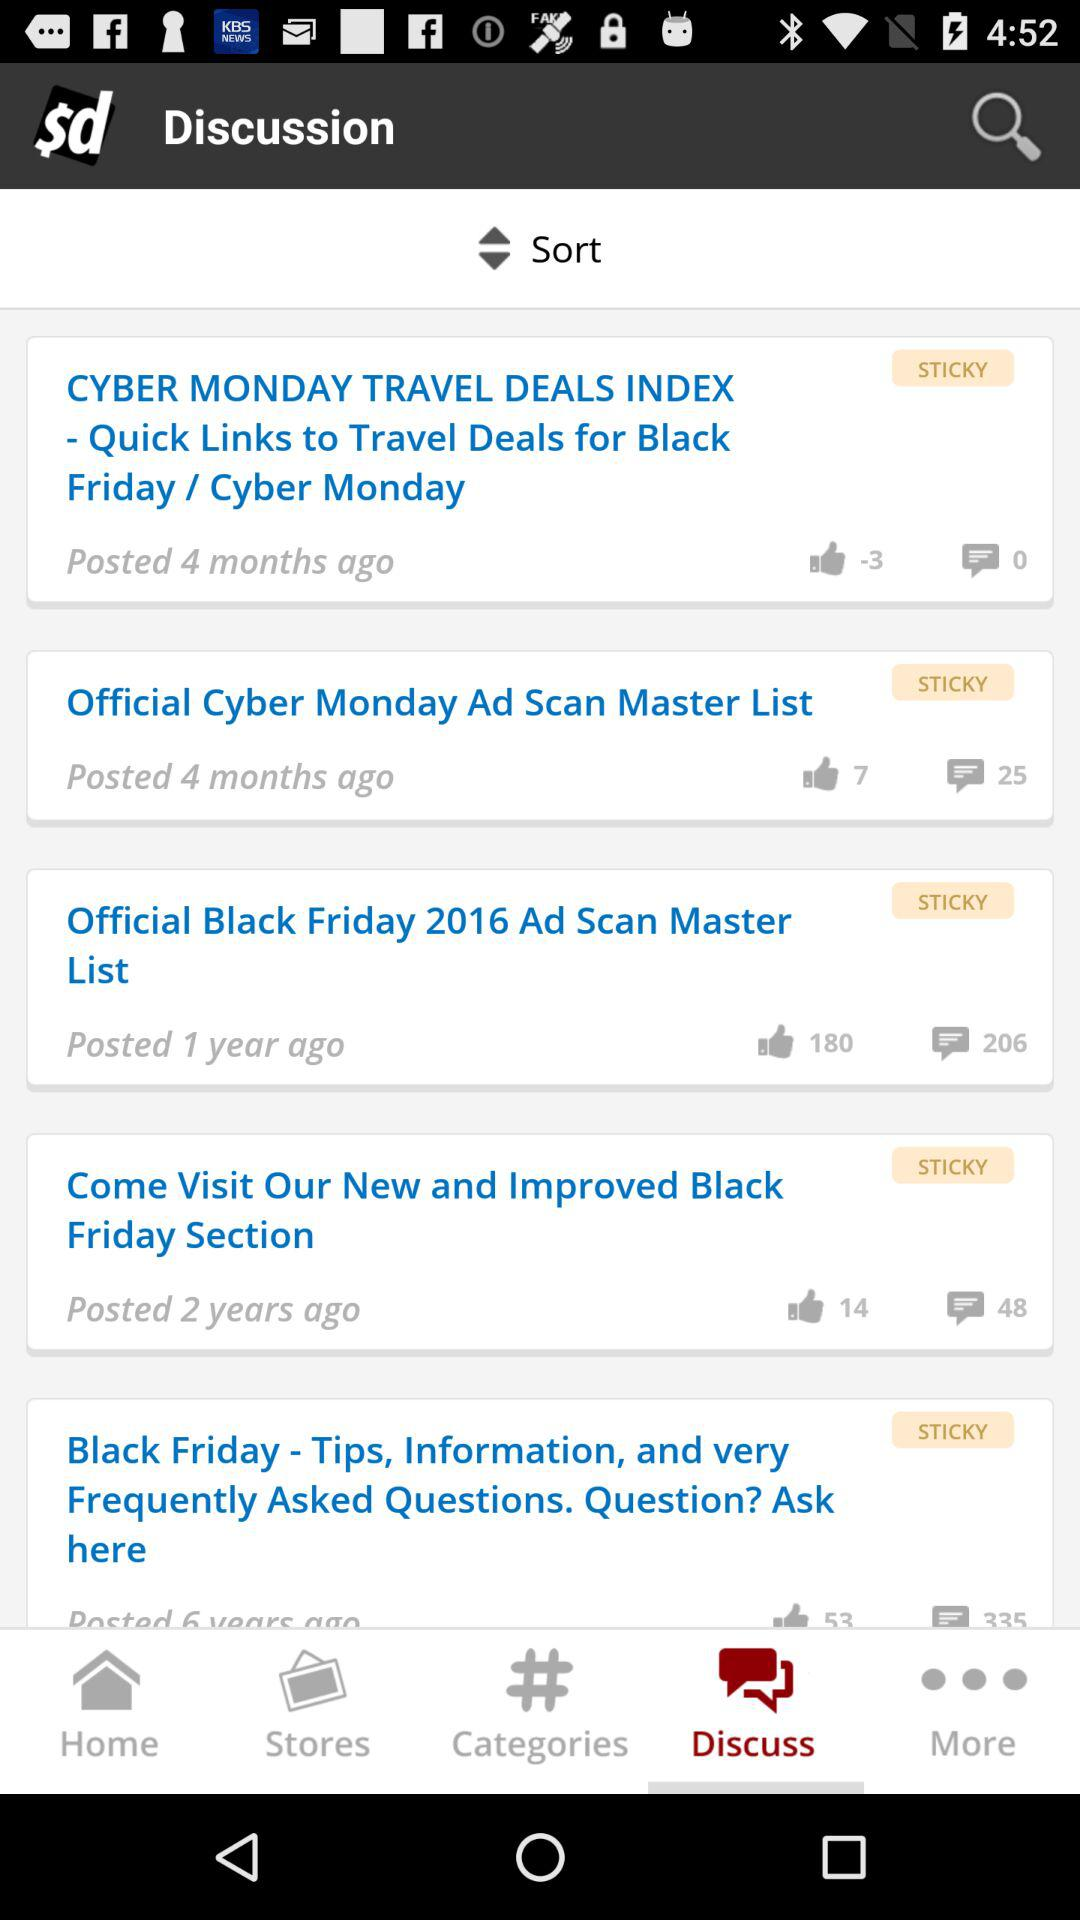When was the post "Official Black Friday 2016 Ad Scan Master List" posted? The post was posted 1 year ago. 